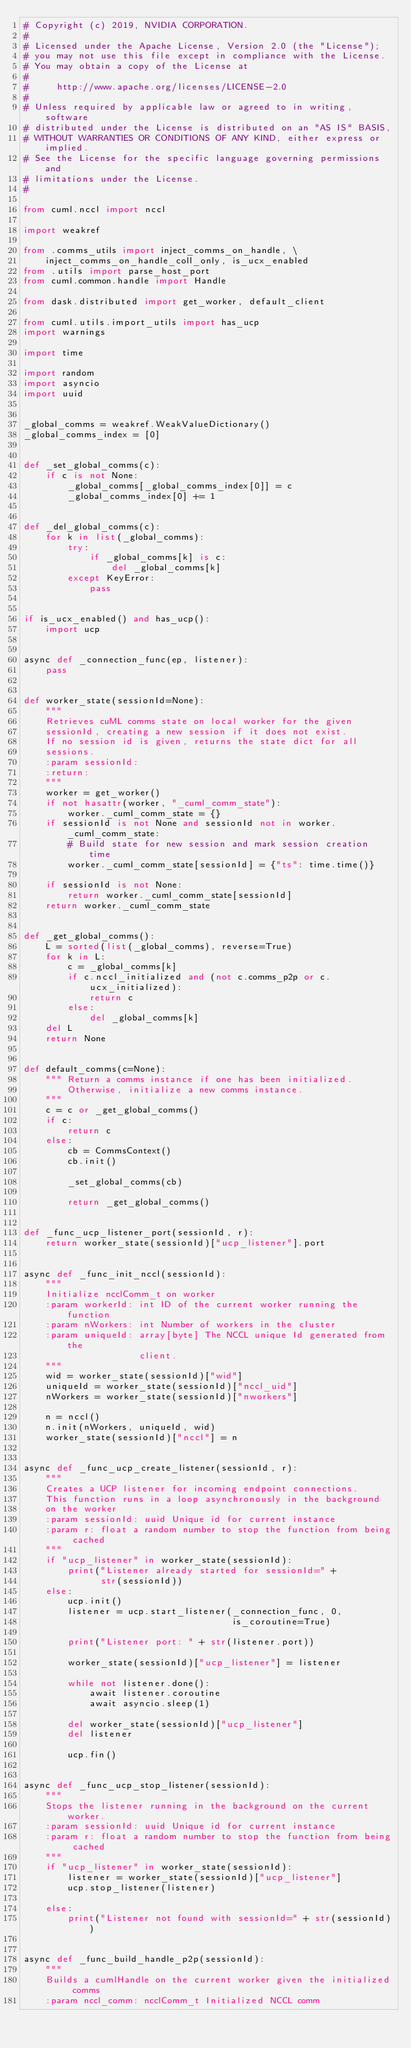Convert code to text. <code><loc_0><loc_0><loc_500><loc_500><_Python_># Copyright (c) 2019, NVIDIA CORPORATION.
#
# Licensed under the Apache License, Version 2.0 (the "License");
# you may not use this file except in compliance with the License.
# You may obtain a copy of the License at
#
#     http://www.apache.org/licenses/LICENSE-2.0
#
# Unless required by applicable law or agreed to in writing, software
# distributed under the License is distributed on an "AS IS" BASIS,
# WITHOUT WARRANTIES OR CONDITIONS OF ANY KIND, either express or implied.
# See the License for the specific language governing permissions and
# limitations under the License.
#

from cuml.nccl import nccl

import weakref

from .comms_utils import inject_comms_on_handle, \
    inject_comms_on_handle_coll_only, is_ucx_enabled
from .utils import parse_host_port
from cuml.common.handle import Handle

from dask.distributed import get_worker, default_client

from cuml.utils.import_utils import has_ucp
import warnings

import time

import random
import asyncio
import uuid


_global_comms = weakref.WeakValueDictionary()
_global_comms_index = [0]


def _set_global_comms(c):
    if c is not None:
        _global_comms[_global_comms_index[0]] = c
        _global_comms_index[0] += 1


def _del_global_comms(c):
    for k in list(_global_comms):
        try:
            if _global_comms[k] is c:
                del _global_comms[k]
        except KeyError:
            pass


if is_ucx_enabled() and has_ucp():
    import ucp


async def _connection_func(ep, listener):
    pass


def worker_state(sessionId=None):
    """
    Retrieves cuML comms state on local worker for the given
    sessionId, creating a new session if it does not exist.
    If no session id is given, returns the state dict for all
    sessions.
    :param sessionId:
    :return:
    """
    worker = get_worker()
    if not hasattr(worker, "_cuml_comm_state"):
        worker._cuml_comm_state = {}
    if sessionId is not None and sessionId not in worker._cuml_comm_state:
        # Build state for new session and mark session creation time
        worker._cuml_comm_state[sessionId] = {"ts": time.time()}

    if sessionId is not None:
        return worker._cuml_comm_state[sessionId]
    return worker._cuml_comm_state


def _get_global_comms():
    L = sorted(list(_global_comms), reverse=True)
    for k in L:
        c = _global_comms[k]
        if c.nccl_initialized and (not c.comms_p2p or c.ucx_initialized):
            return c
        else:
            del _global_comms[k]
    del L
    return None


def default_comms(c=None):
    """ Return a comms instance if one has been initialized.
        Otherwise, initialize a new comms instance.
    """
    c = c or _get_global_comms()
    if c:
        return c
    else:
        cb = CommsContext()
        cb.init()

        _set_global_comms(cb)

        return _get_global_comms()


def _func_ucp_listener_port(sessionId, r):
    return worker_state(sessionId)["ucp_listener"].port


async def _func_init_nccl(sessionId):
    """
    Initialize ncclComm_t on worker
    :param workerId: int ID of the current worker running the function
    :param nWorkers: int Number of workers in the cluster
    :param uniqueId: array[byte] The NCCL unique Id generated from the
                     client.
    """
    wid = worker_state(sessionId)["wid"]
    uniqueId = worker_state(sessionId)["nccl_uid"]
    nWorkers = worker_state(sessionId)["nworkers"]

    n = nccl()
    n.init(nWorkers, uniqueId, wid)
    worker_state(sessionId)["nccl"] = n


async def _func_ucp_create_listener(sessionId, r):
    """
    Creates a UCP listener for incoming endpoint connections.
    This function runs in a loop asynchronously in the background
    on the worker
    :param sessionId: uuid Unique id for current instance
    :param r: float a random number to stop the function from being cached
    """
    if "ucp_listener" in worker_state(sessionId):
        print("Listener already started for sessionId=" +
              str(sessionId))
    else:
        ucp.init()
        listener = ucp.start_listener(_connection_func, 0,
                                      is_coroutine=True)

        print("Listener port: " + str(listener.port))

        worker_state(sessionId)["ucp_listener"] = listener

        while not listener.done():
            await listener.coroutine
            await asyncio.sleep(1)

        del worker_state(sessionId)["ucp_listener"]
        del listener

        ucp.fin()


async def _func_ucp_stop_listener(sessionId):
    """
    Stops the listener running in the background on the current worker.
    :param sessionId: uuid Unique id for current instance
    :param r: float a random number to stop the function from being cached
    """
    if "ucp_listener" in worker_state(sessionId):
        listener = worker_state(sessionId)["ucp_listener"]
        ucp.stop_listener(listener)

    else:
        print("Listener not found with sessionId=" + str(sessionId))


async def _func_build_handle_p2p(sessionId):
    """
    Builds a cumlHandle on the current worker given the initialized comms
    :param nccl_comm: ncclComm_t Initialized NCCL comm</code> 